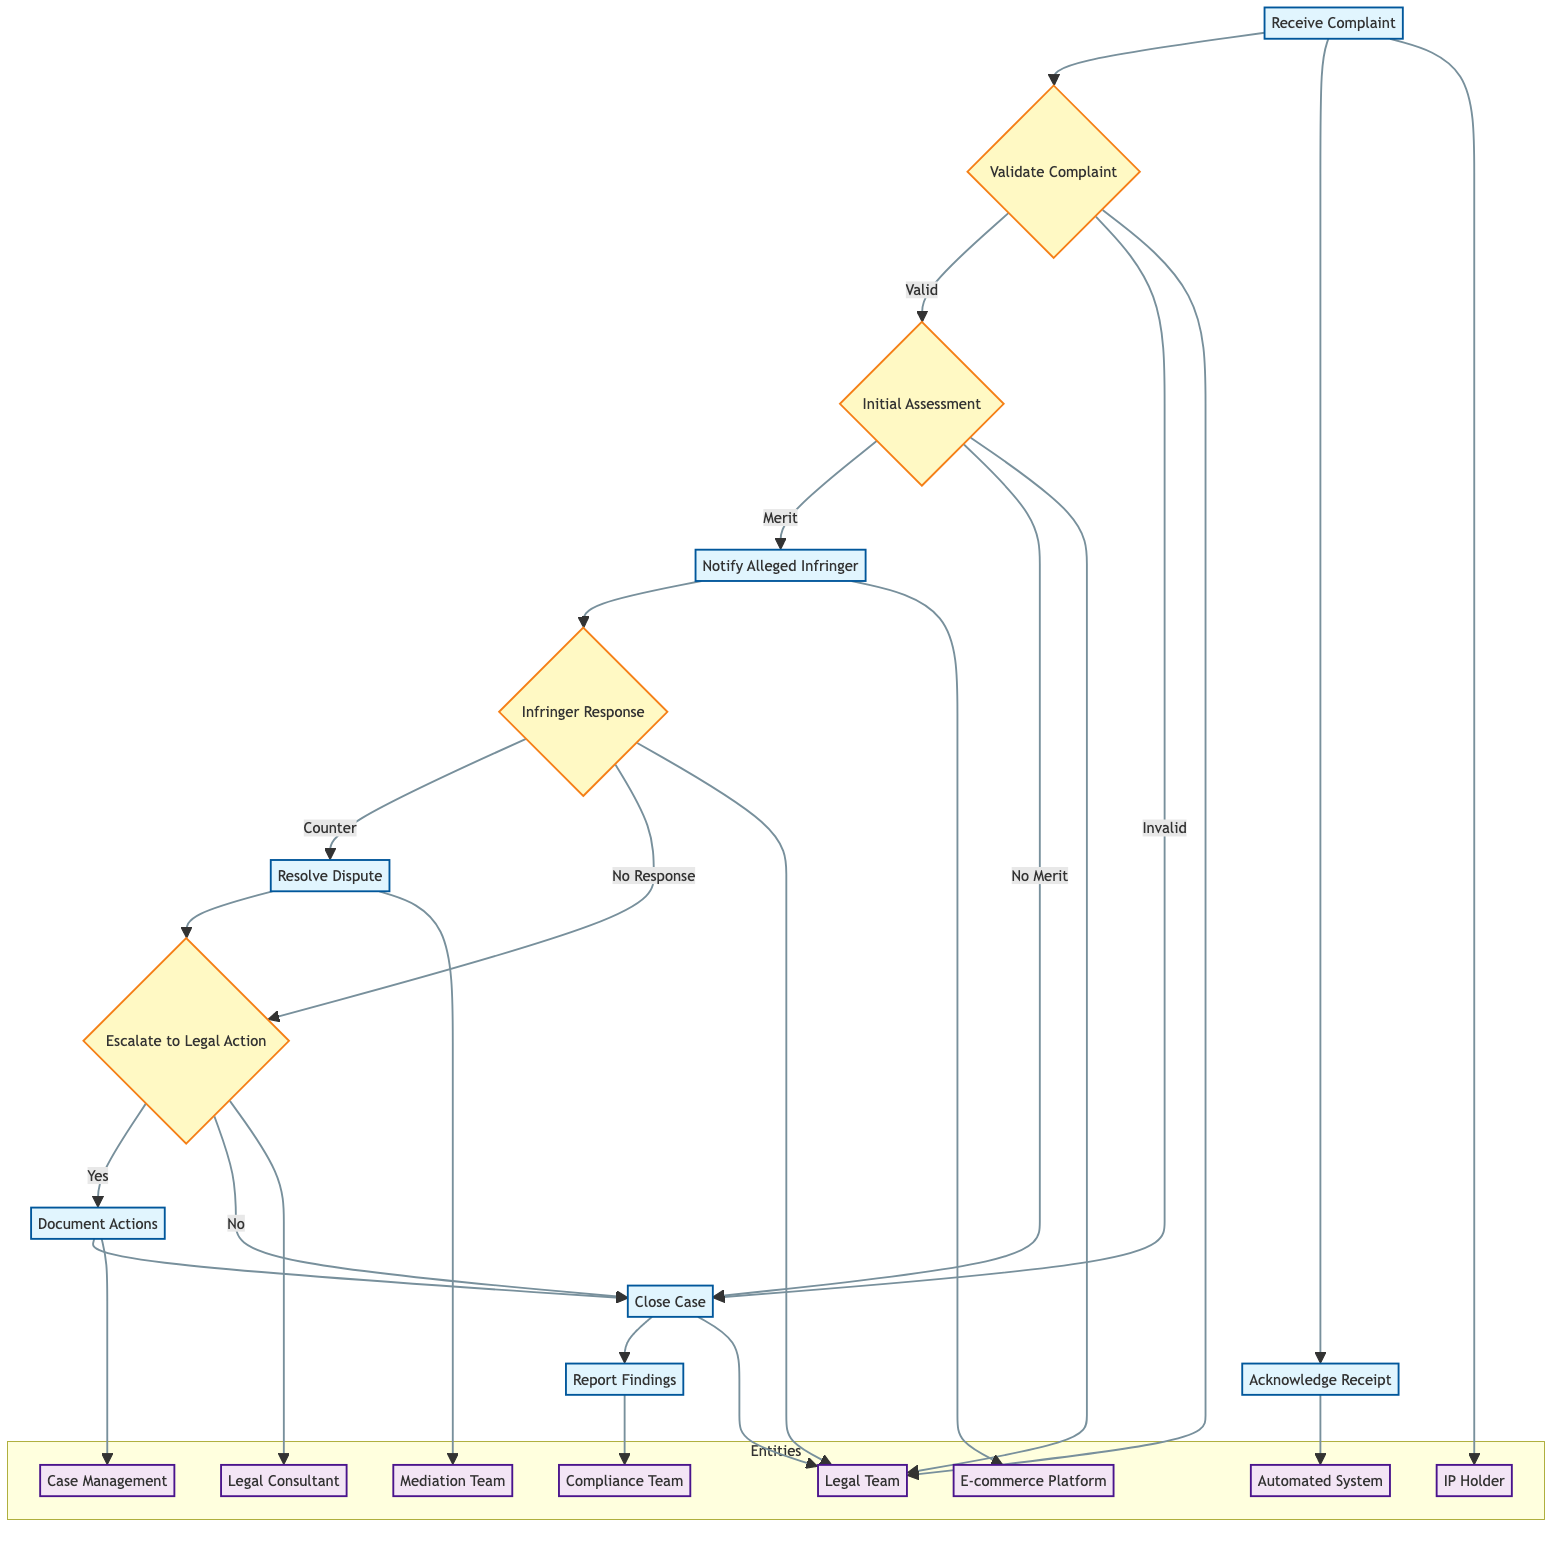What is the first process in the flow chart? The first process shown in the flow chart is "Receive Complaint," where the IP holder presents their complaint regarding intellectual property infringement.
Answer: Receive Complaint How many outcomes are there from the "Validate Complaint" decision? The "Validate Complaint" decision has two possible outcomes: "Valid" and "Invalid." Each of these outcomes leads to a different next step in the process.
Answer: Two What follows the "Initial Assessment" if the claim has no merit? If the initial assessment determines that the claim has no merit, the next step is to "Close Case," effectively concluding the claim handling process at that point.
Answer: Close Case Who is responsible for notifying the alleged infringer? The "E-commerce Platform" is responsible for notifying the alleged infringer about the claim and providing an opportunity for their response.
Answer: E-commerce Platform What happens if the alleged infringer does not respond? If there is no response from the alleged infringer, the flowchart indicates that the next step is to "Escalate to Legal Action," which means the case may be taken to legal proceedings.
Answer: Escalate to Legal Action Which entity documents all actions taken during the claim handling process? The entity responsible for documenting all actions and communications during the claim process is the "Case Management System," ensuring a record of the proceedings is maintained.
Answer: Case Management System After resolving a dispute, which process directly follows? After attempting to resolve the dispute through mediation, the flowchart shows that the next action is to "Escalate to Legal Action," indicating that unresolved disputes may require legal intervention.
Answer: Escalate to Legal Action What is the final step in the process? The final step in the flowchart is "Report Findings," which involves reporting the outcomes to both parties and ensuring compliance records are updated for future reference.
Answer: Report Findings What decision comes after the "Infringer Response" process? The decision that follows the "Infringer Response" process is whether to "Escalate to Legal Action," depending on the response received from the alleged infringer.
Answer: Escalate to Legal Action 